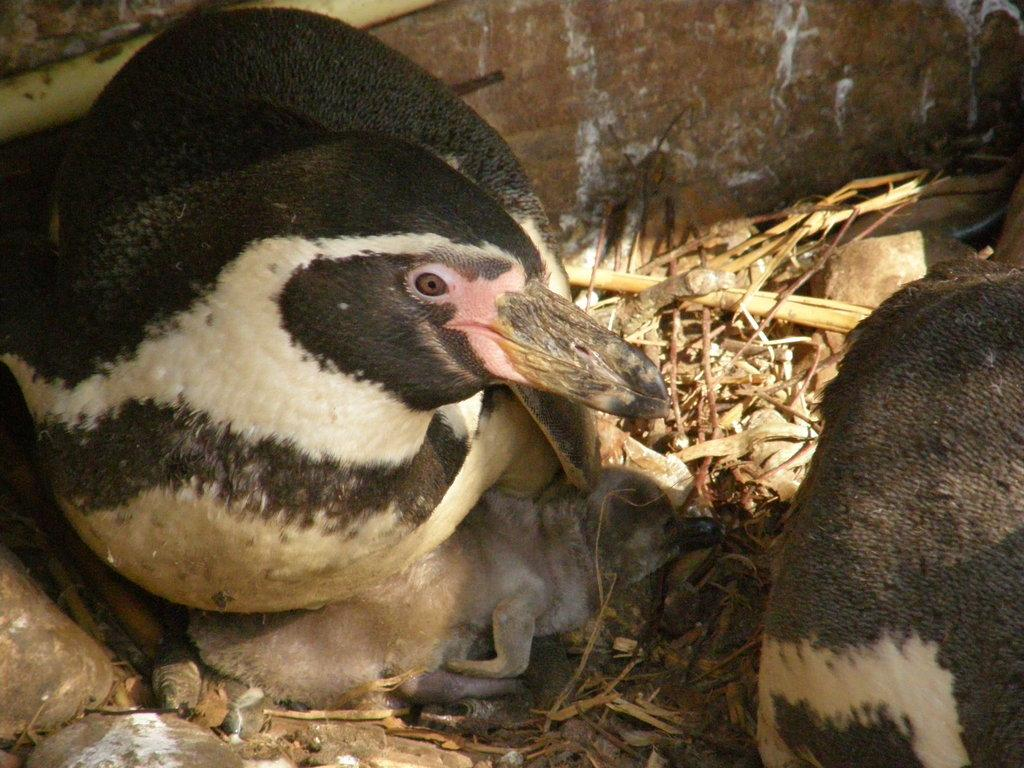What type of animals can be seen in the image? There are birds in the image. What type of vegetation is present in the image? There is dried grass in the image. What other objects can be seen in the image? There are stones in the image. What can be seen in the background of the image? There is a wall in the background of the image. Where is the nearest park to the location of the image? The provided facts do not give any information about the location of the image or the presence of a park, so it cannot be determined from the image. 